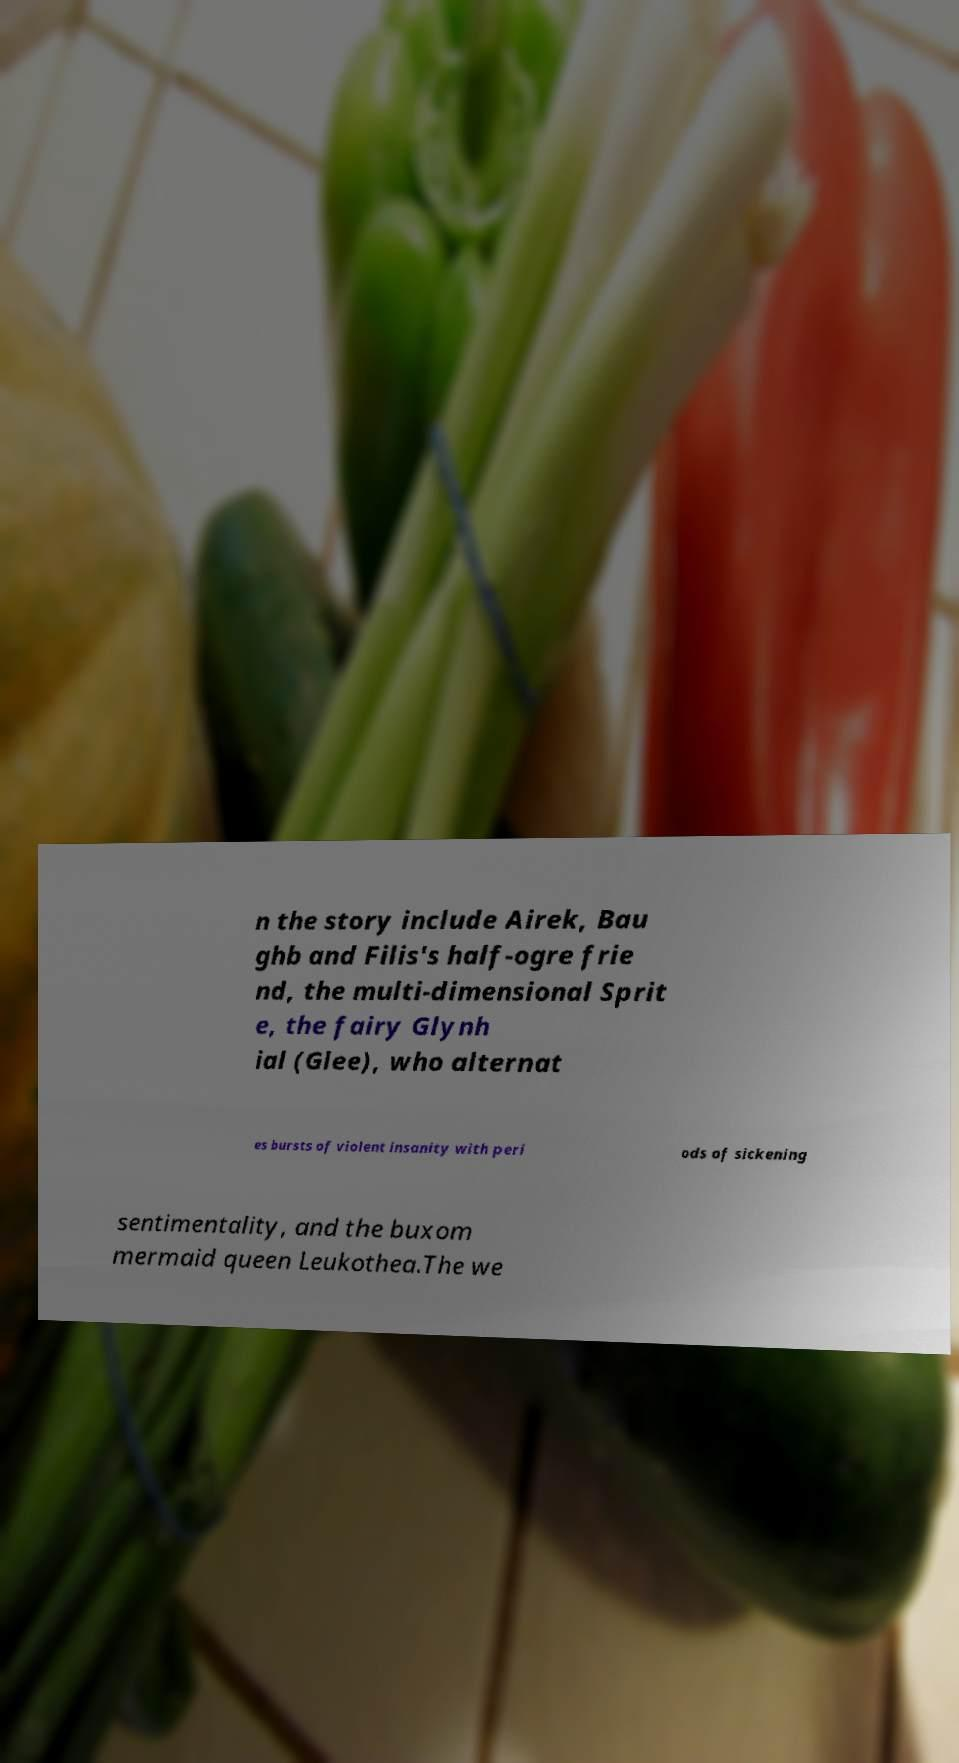Please identify and transcribe the text found in this image. n the story include Airek, Bau ghb and Filis's half-ogre frie nd, the multi-dimensional Sprit e, the fairy Glynh ial (Glee), who alternat es bursts of violent insanity with peri ods of sickening sentimentality, and the buxom mermaid queen Leukothea.The we 